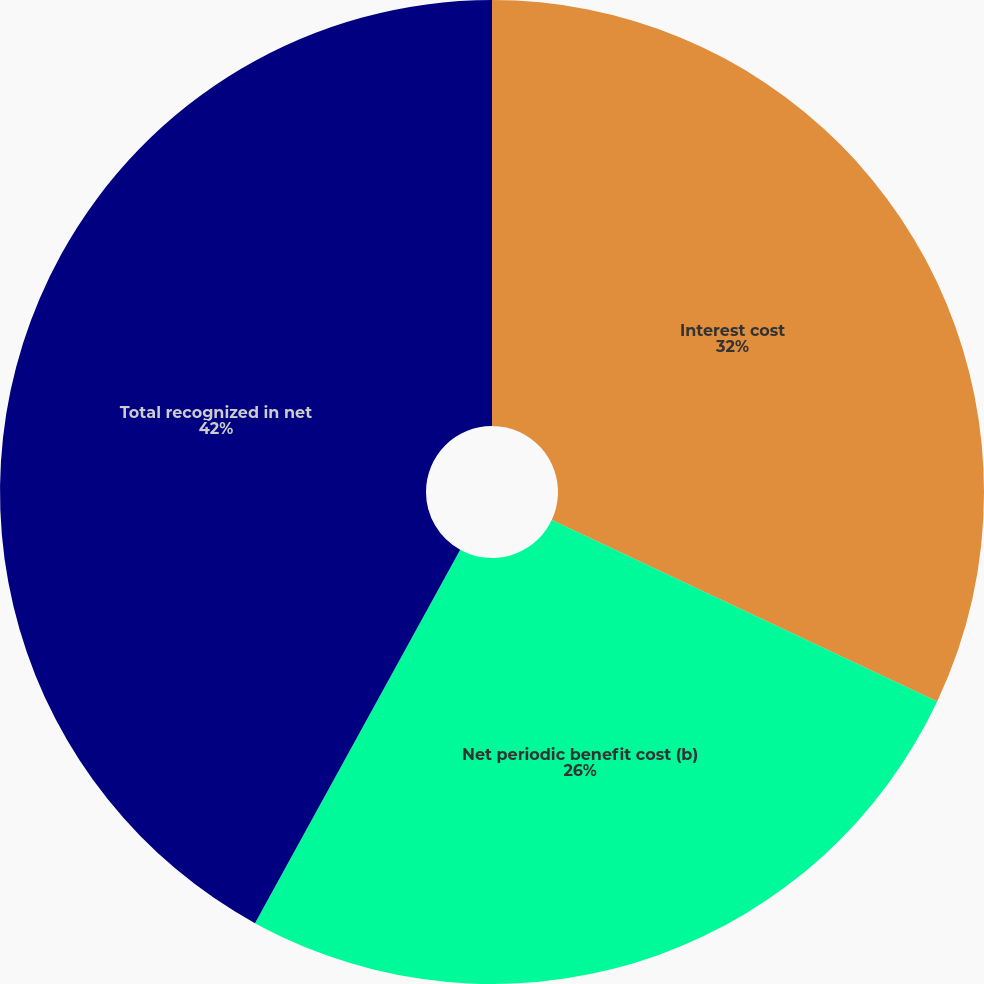<chart> <loc_0><loc_0><loc_500><loc_500><pie_chart><fcel>Interest cost<fcel>Net periodic benefit cost (b)<fcel>Total recognized in net<nl><fcel>32.0%<fcel>26.0%<fcel>42.0%<nl></chart> 